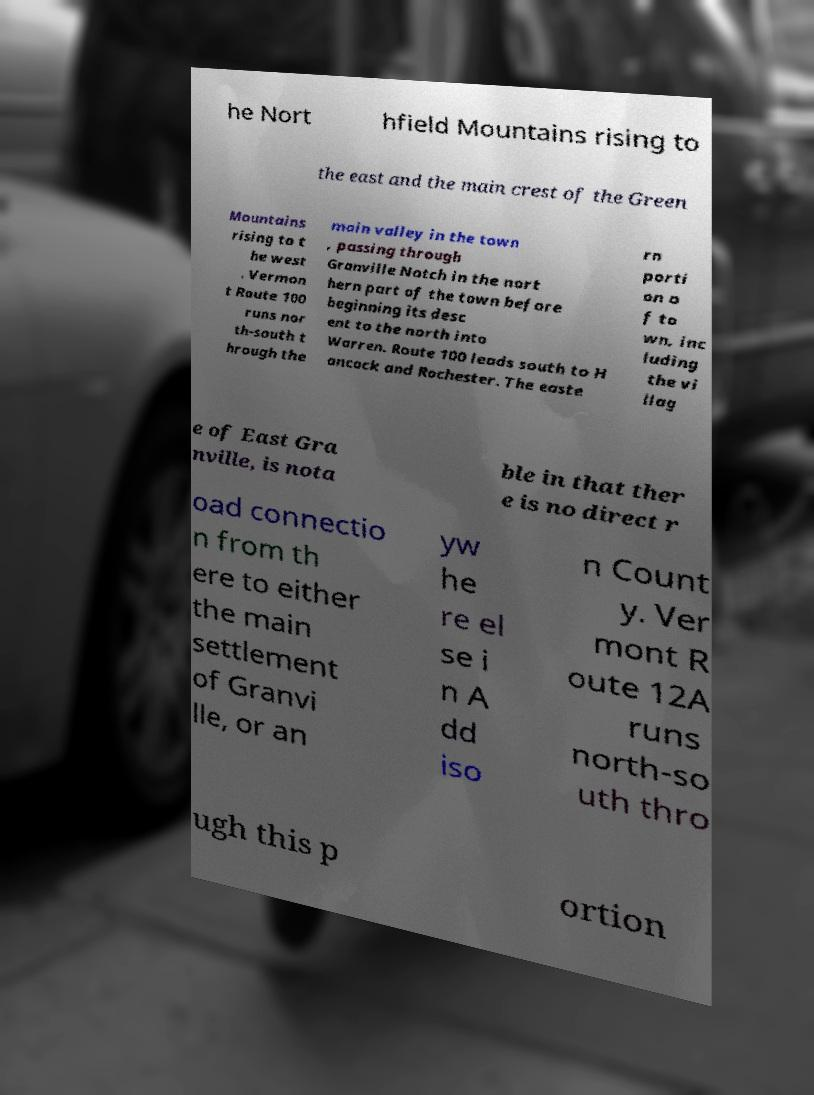I need the written content from this picture converted into text. Can you do that? he Nort hfield Mountains rising to the east and the main crest of the Green Mountains rising to t he west . Vermon t Route 100 runs nor th-south t hrough the main valley in the town , passing through Granville Notch in the nort hern part of the town before beginning its desc ent to the north into Warren. Route 100 leads south to H ancock and Rochester. The easte rn porti on o f to wn, inc luding the vi llag e of East Gra nville, is nota ble in that ther e is no direct r oad connectio n from th ere to either the main settlement of Granvi lle, or an yw he re el se i n A dd iso n Count y. Ver mont R oute 12A runs north-so uth thro ugh this p ortion 